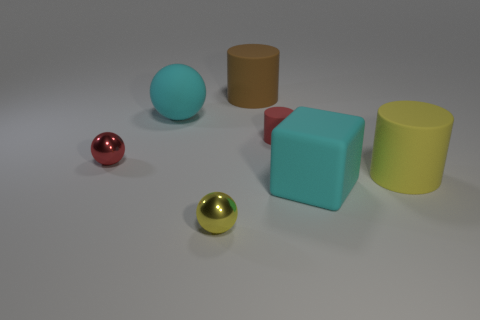Add 3 big shiny spheres. How many objects exist? 10 Subtract all spheres. How many objects are left? 4 Add 3 tiny red metallic objects. How many tiny red metallic objects are left? 4 Add 7 big yellow rubber things. How many big yellow rubber things exist? 8 Subtract 1 brown cylinders. How many objects are left? 6 Subtract all big brown rubber cylinders. Subtract all small rubber objects. How many objects are left? 5 